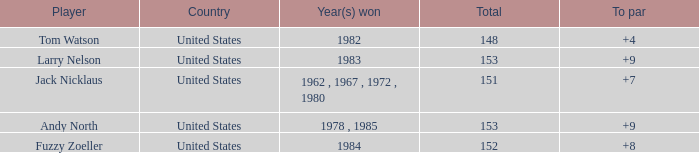What is the Country of the Player with a Total less than 153 and Year(s) won of 1984? United States. 